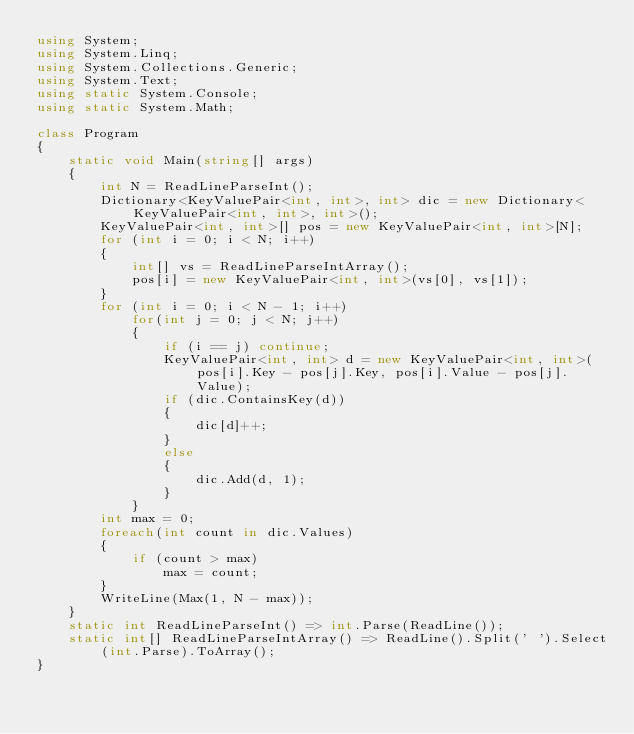<code> <loc_0><loc_0><loc_500><loc_500><_C#_>using System;
using System.Linq;
using System.Collections.Generic;
using System.Text;
using static System.Console;
using static System.Math;

class Program
{
    static void Main(string[] args)
    {
        int N = ReadLineParseInt();
        Dictionary<KeyValuePair<int, int>, int> dic = new Dictionary<KeyValuePair<int, int>, int>();
        KeyValuePair<int, int>[] pos = new KeyValuePair<int, int>[N];
        for (int i = 0; i < N; i++)
        {
            int[] vs = ReadLineParseIntArray();
            pos[i] = new KeyValuePair<int, int>(vs[0], vs[1]);
        }
        for (int i = 0; i < N - 1; i++)
            for(int j = 0; j < N; j++)
            {
                if (i == j) continue;
                KeyValuePair<int, int> d = new KeyValuePair<int, int>(pos[i].Key - pos[j].Key, pos[i].Value - pos[j].Value);
                if (dic.ContainsKey(d))
                {
                    dic[d]++;
                }
                else
                {
                    dic.Add(d, 1);
                }
            }
        int max = 0;
        foreach(int count in dic.Values)
        {
            if (count > max)
                max = count;
        }
        WriteLine(Max(1, N - max));
    }
    static int ReadLineParseInt() => int.Parse(ReadLine());
    static int[] ReadLineParseIntArray() => ReadLine().Split(' ').Select(int.Parse).ToArray();
}</code> 